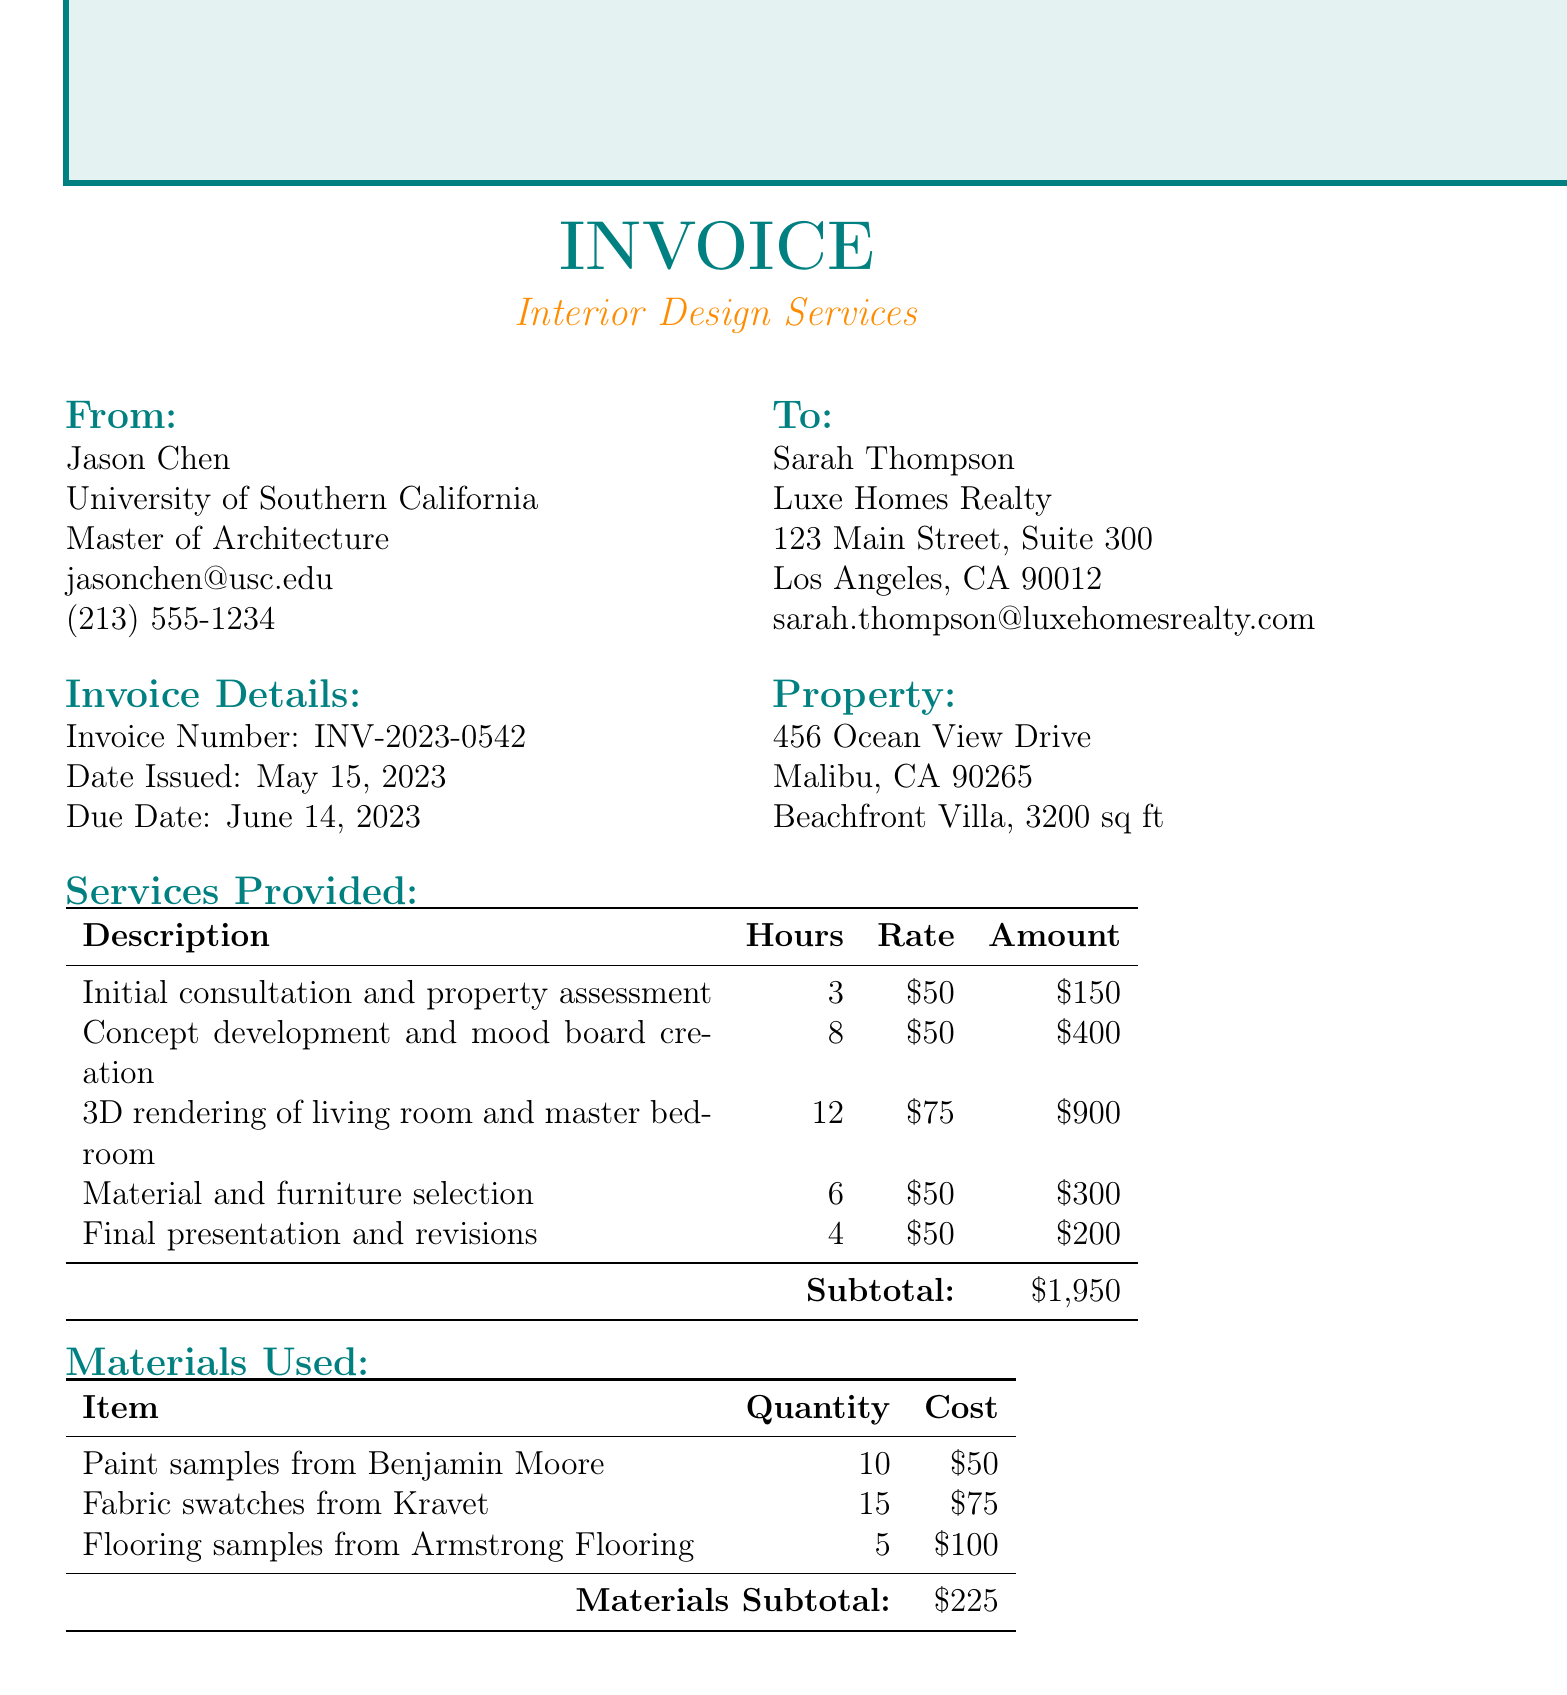what is the invoice number? The invoice number is clearly indicated in the document as part of the invoice details.
Answer: INV-2023-0542 who is the student designer? The student's name is mentioned at the beginning of the document, specifying who provided the design services.
Answer: Jason Chen when was the invoice issued? The date issued is noted in the invoice details section of the document.
Answer: May 15, 2023 what type of property is this invoice for? The type of property is mentioned in the property details section, reflecting the nature of the design services provided.
Answer: Beachfront Villa what is the total amount due? The total amount due is found in the payment summary at the end of the document.
Answer: 2381.63 how many hours were spent on 3D rendering? The document specifies the number of hours attributed to each service, including this one.
Answer: 12 what are two benefits of collaboration mentioned? The document lists several benefits of collaboration, which provides insight into the purpose of the project.
Answer: Fresh, innovative design ideas and Cost-effective solutions what is the tax rate applied to the services? The tax rate is indicated as part of the financial details in the document.
Answer: 9.5% 